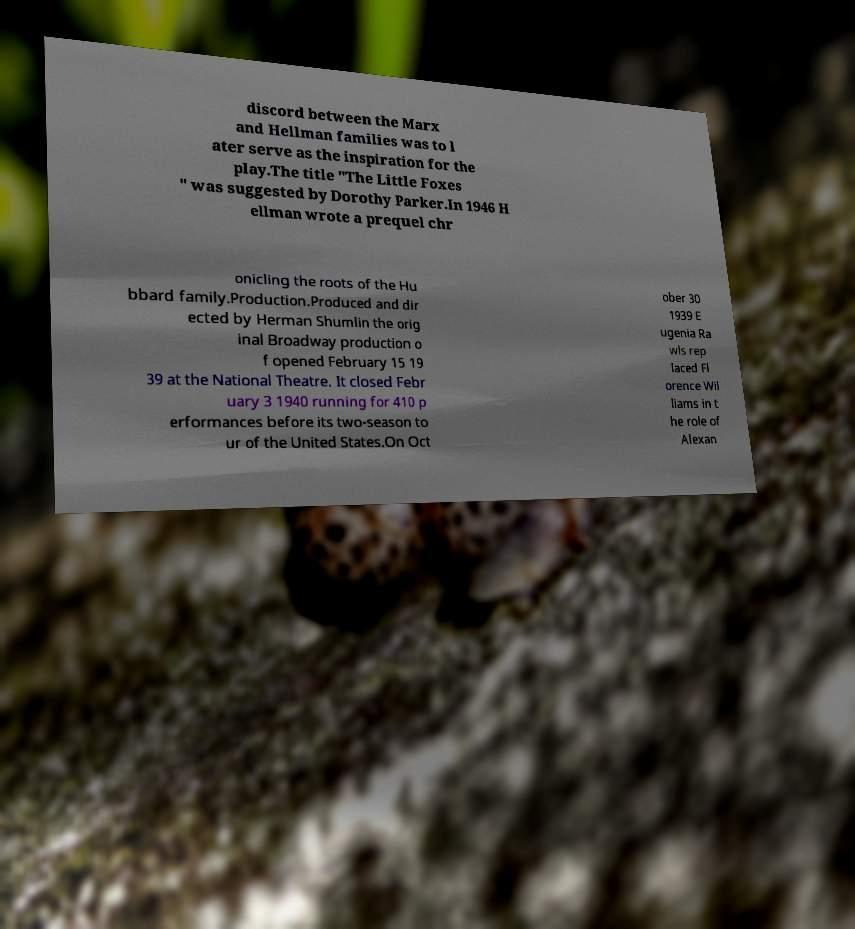For documentation purposes, I need the text within this image transcribed. Could you provide that? discord between the Marx and Hellman families was to l ater serve as the inspiration for the play.The title "The Little Foxes " was suggested by Dorothy Parker.In 1946 H ellman wrote a prequel chr onicling the roots of the Hu bbard family.Production.Produced and dir ected by Herman Shumlin the orig inal Broadway production o f opened February 15 19 39 at the National Theatre. It closed Febr uary 3 1940 running for 410 p erformances before its two-season to ur of the United States.On Oct ober 30 1939 E ugenia Ra wls rep laced Fl orence Wil liams in t he role of Alexan 